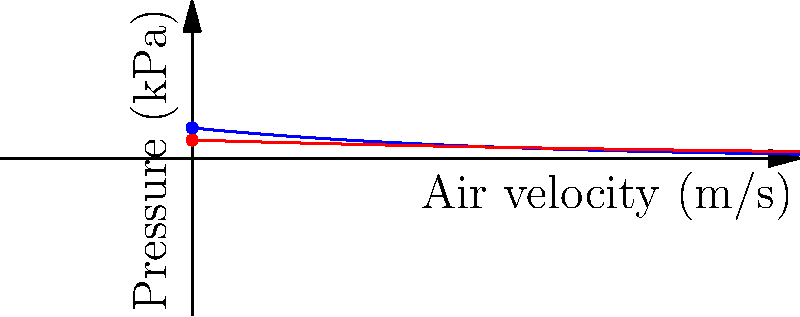As a trumpet player, you understand the importance of airflow dynamics in your instrument. The graph shows the relationship between air velocity and pressure for open and closed valves in a trumpet. If the initial pressure at zero velocity is 0.5 kPa for an open valve and 0.3 kPa for a closed valve, what is the percentage increase in initial pressure when opening a closed valve? To solve this problem, we'll follow these steps:

1. Identify the initial pressures:
   - Open valve: $P_{open} = 0.5$ kPa
   - Closed valve: $P_{closed} = 0.3$ kPa

2. Calculate the difference in pressure:
   $\Delta P = P_{open} - P_{closed} = 0.5 - 0.3 = 0.2$ kPa

3. Calculate the percentage increase:
   Percentage increase = $\frac{\Delta P}{P_{closed}} \times 100\%$
   
   $= \frac{0.2}{0.3} \times 100\%$
   
   $= 0.6666... \times 100\%$
   
   $\approx 66.67\%$

Therefore, opening a closed valve results in approximately a 66.67% increase in initial pressure.
Answer: 66.67% 